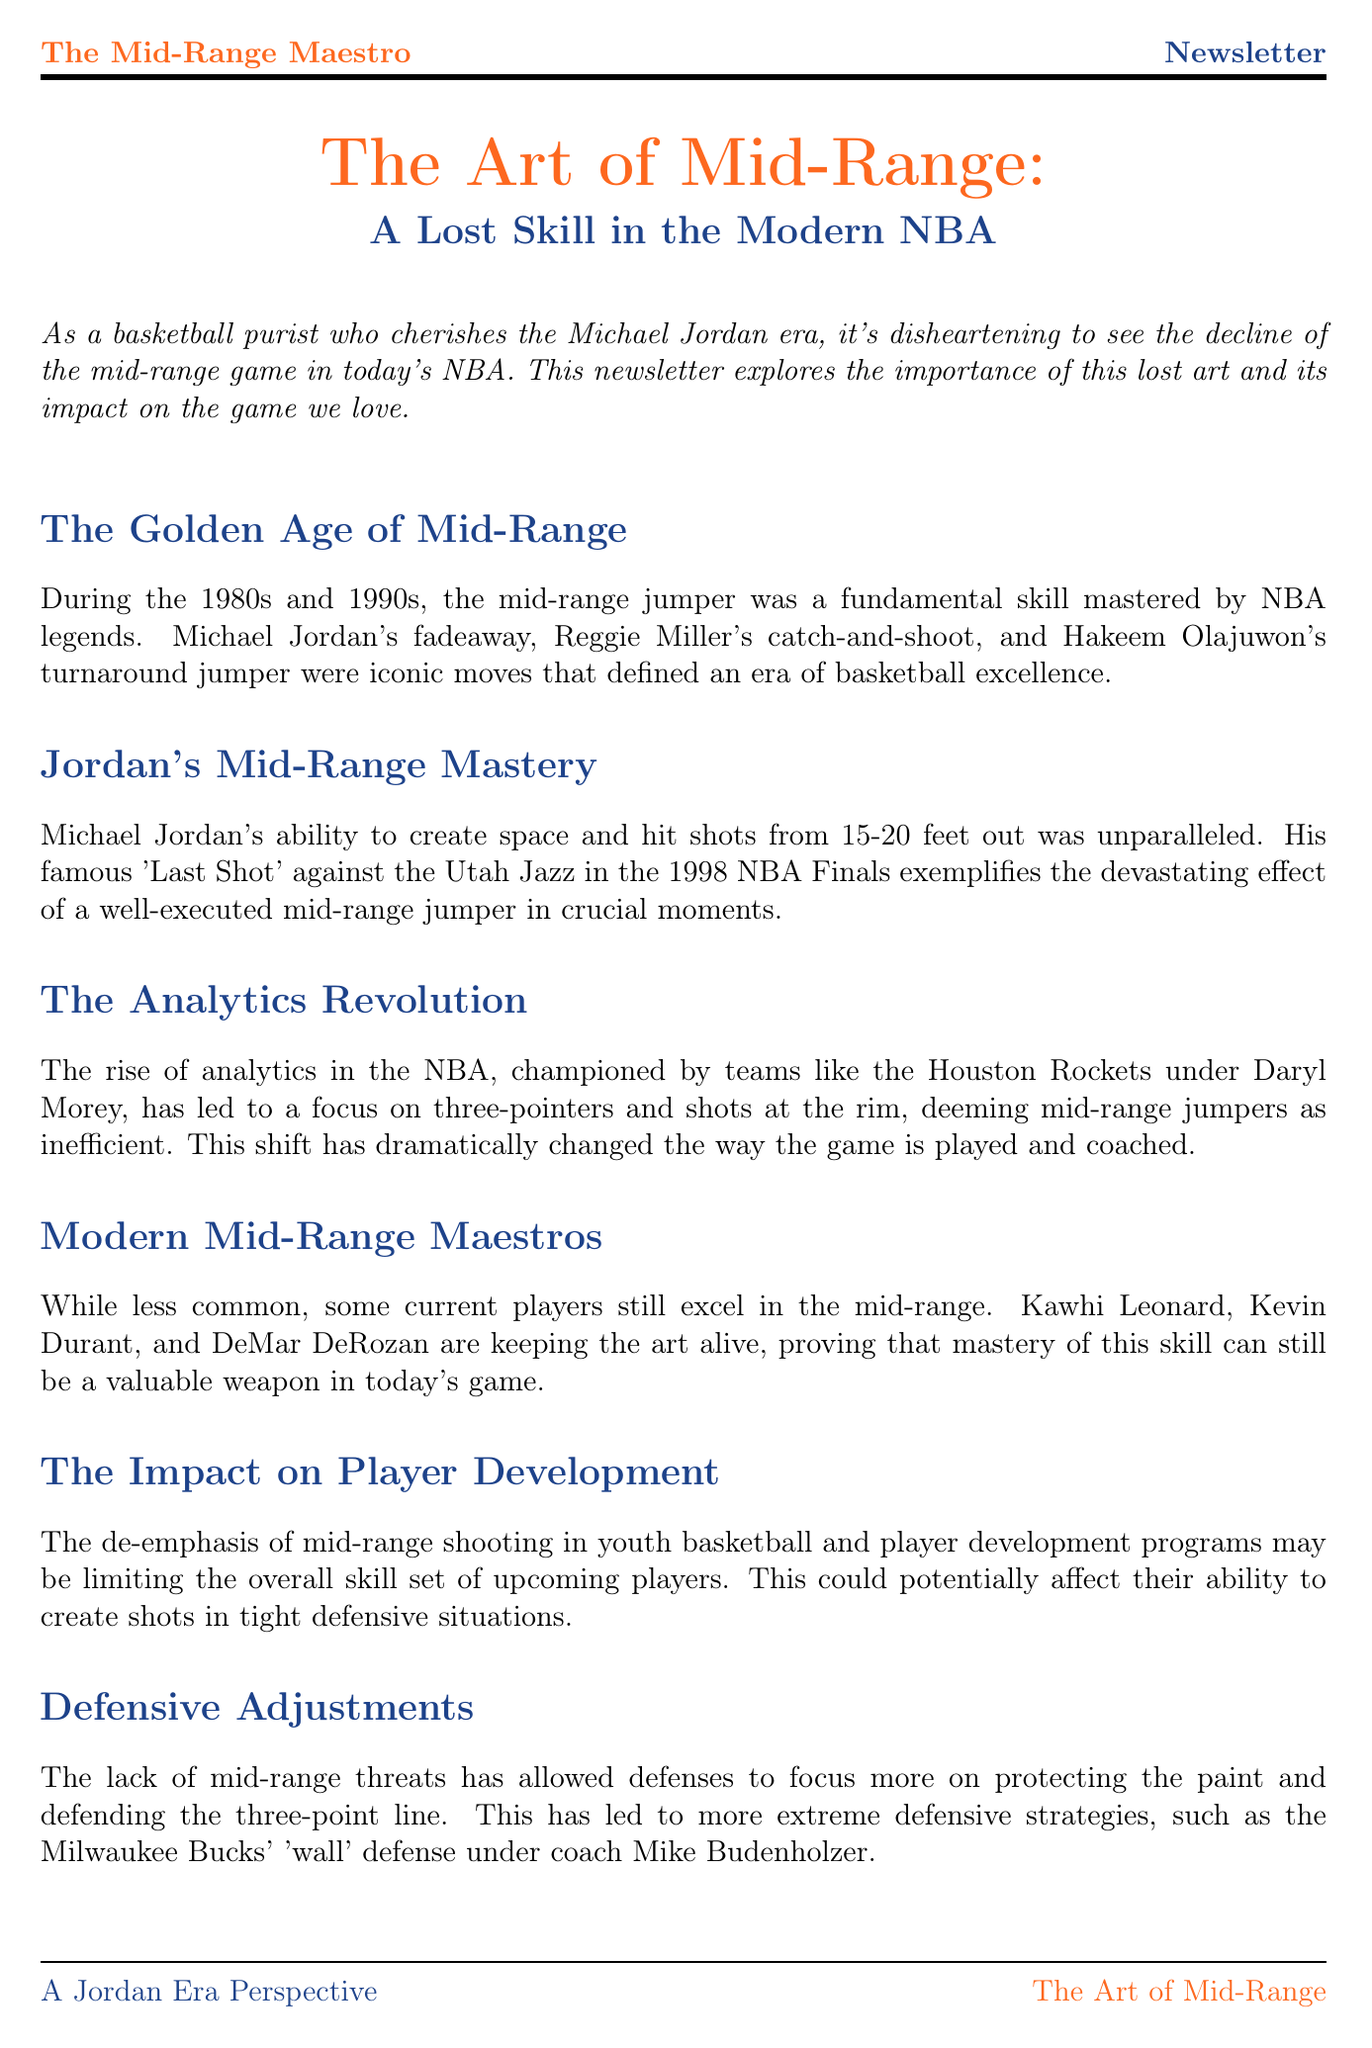What is the title of the newsletter? The title of the newsletter is presented at the beginning of the document.
Answer: The Art of Mid-Range: A Lost Skill in the Modern NBA Who are the modern players mentioned as excelling in the mid-range? The newsletter lists current players who are highlighted for their mid-range skills.
Answer: Kawhi Leonard, Kevin Durant, DeMar DeRozan What era is considered the golden age of mid-range shooting? The document specifies the time frame when the mid-range game flourished.
Answer: 1980s and 1990s What significant shot by Michael Jordan is mentioned in the document? The newsletter provides a specific example of Jordan's skill in mid-range shooting during a critical moment.
Answer: 'Last Shot' against the Utah Jazz What impact has the analytics revolution had on mid-range shooting? The newsletter explains the effect of analytics on shot selection in the NBA.
Answer: Deeming mid-range jumpers as inefficient How does the lack of mid-range threats affect defensive strategies? The document discusses changes in defensive approaches due to the decline of mid-range shooting.
Answer: Allows defenses to focus more on protecting the paint and defending the three-point line What does the conclusion state about the mid-range game? The conclusion emphasizes the historical importance of mid-range shooting in basketball.
Answer: Essential part of basketball's rich history 